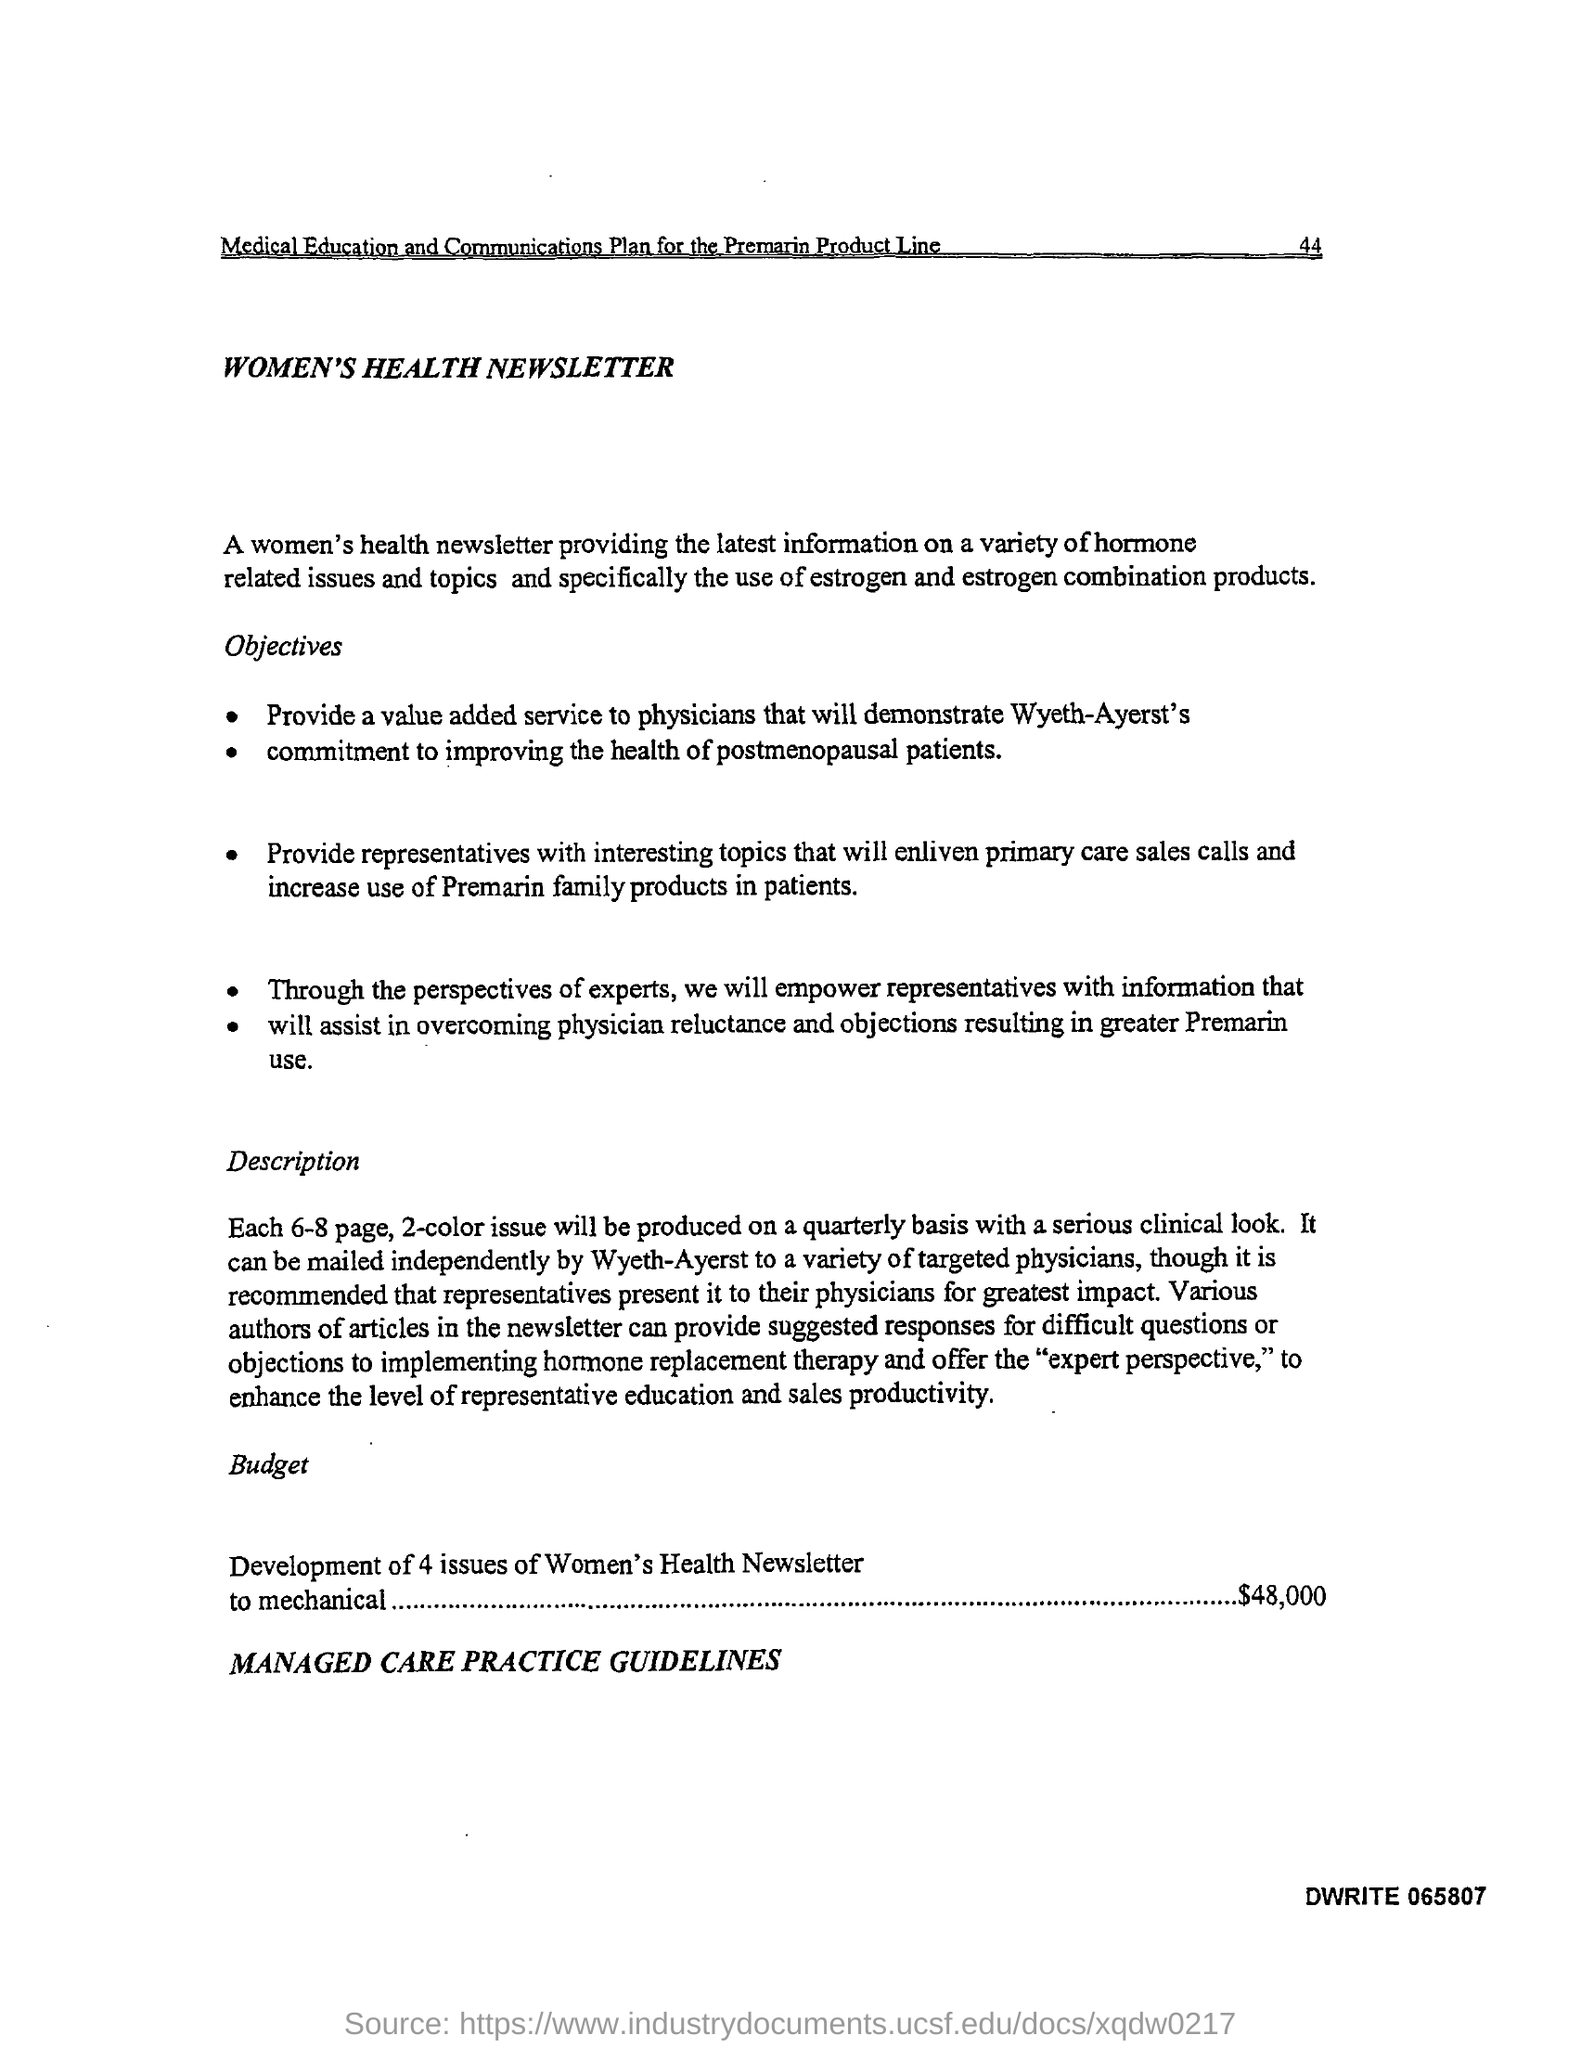Draw attention to some important aspects in this diagram. The document in question is titled "Women's Health Newsletter. The budget for the development of four issues of the Women's Health newsletter, which will be mechanical in nature, is $48,000. 